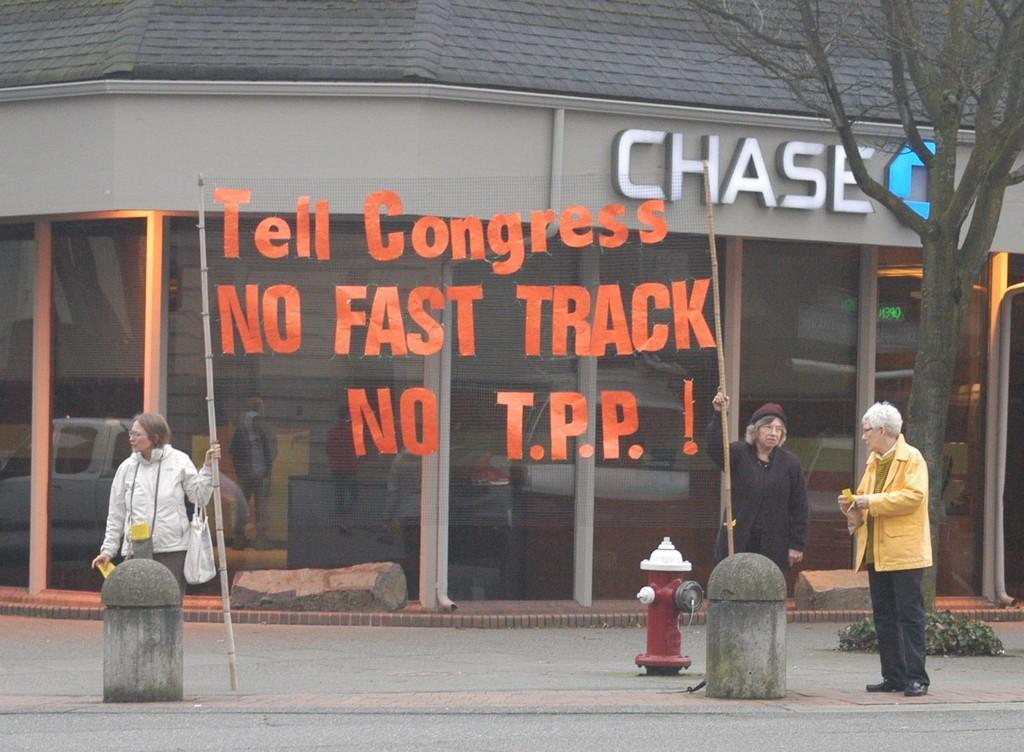Could you give a brief overview of what you see in this image? In this image we can see there are three people standing on the road and holding a banner. In the middle of the image there is a fire hydrant. On the right side there is a tree, back of them there is a stall. 